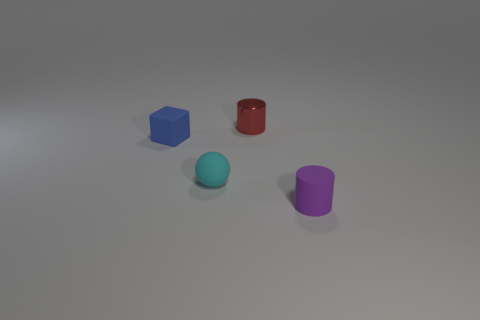How does the lighting affect the perception of the objects? The lighting in the image seems to come from above, casting slight shadows beneath the objects, which helps to enhance their three-dimensional form and gives depth to the visual scene. Additionally, the glossy finish of the red cylinder reflects the light, highlighting its texture compared to the matte surfaces of the other objects. 